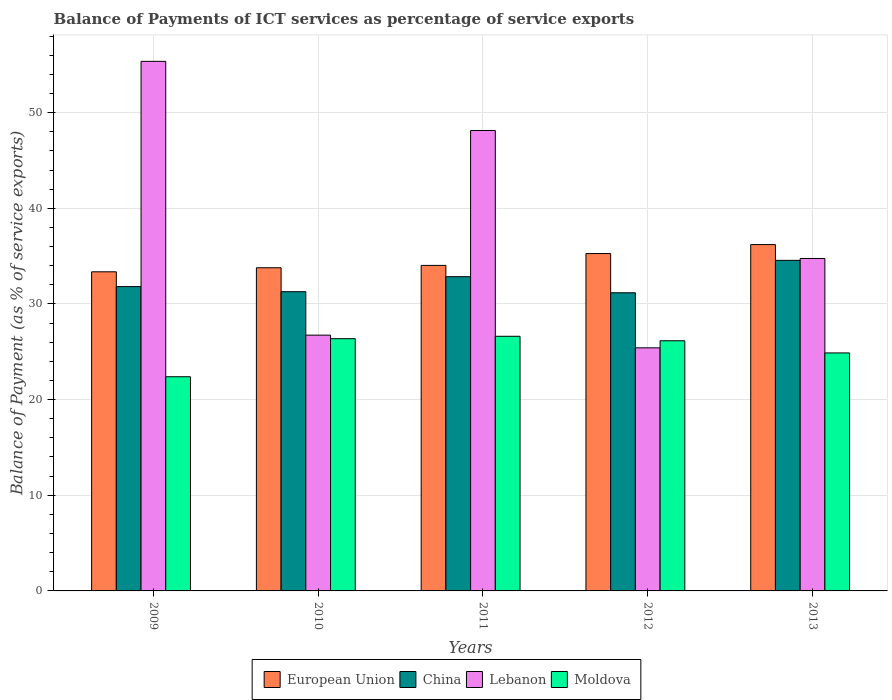Are the number of bars per tick equal to the number of legend labels?
Make the answer very short. Yes. Are the number of bars on each tick of the X-axis equal?
Provide a succinct answer. Yes. How many bars are there on the 4th tick from the left?
Your answer should be compact. 4. How many bars are there on the 4th tick from the right?
Provide a short and direct response. 4. In how many cases, is the number of bars for a given year not equal to the number of legend labels?
Provide a short and direct response. 0. What is the balance of payments of ICT services in China in 2013?
Provide a short and direct response. 34.56. Across all years, what is the maximum balance of payments of ICT services in Moldova?
Ensure brevity in your answer.  26.62. Across all years, what is the minimum balance of payments of ICT services in European Union?
Provide a succinct answer. 33.36. What is the total balance of payments of ICT services in European Union in the graph?
Your answer should be very brief. 172.64. What is the difference between the balance of payments of ICT services in Moldova in 2009 and that in 2011?
Offer a terse response. -4.23. What is the difference between the balance of payments of ICT services in Moldova in 2010 and the balance of payments of ICT services in China in 2013?
Your response must be concise. -8.19. What is the average balance of payments of ICT services in China per year?
Give a very brief answer. 32.33. In the year 2010, what is the difference between the balance of payments of ICT services in Lebanon and balance of payments of ICT services in Moldova?
Offer a very short reply. 0.37. What is the ratio of the balance of payments of ICT services in Lebanon in 2009 to that in 2011?
Keep it short and to the point. 1.15. Is the balance of payments of ICT services in Moldova in 2009 less than that in 2013?
Your answer should be very brief. Yes. What is the difference between the highest and the second highest balance of payments of ICT services in Moldova?
Make the answer very short. 0.25. What is the difference between the highest and the lowest balance of payments of ICT services in Moldova?
Offer a terse response. 4.23. Is the sum of the balance of payments of ICT services in Moldova in 2012 and 2013 greater than the maximum balance of payments of ICT services in China across all years?
Keep it short and to the point. Yes. Is it the case that in every year, the sum of the balance of payments of ICT services in European Union and balance of payments of ICT services in China is greater than the sum of balance of payments of ICT services in Moldova and balance of payments of ICT services in Lebanon?
Your answer should be very brief. Yes. What does the 4th bar from the left in 2011 represents?
Your answer should be compact. Moldova. What does the 3rd bar from the right in 2010 represents?
Make the answer very short. China. How many bars are there?
Offer a terse response. 20. Are all the bars in the graph horizontal?
Make the answer very short. No. How many years are there in the graph?
Give a very brief answer. 5. Are the values on the major ticks of Y-axis written in scientific E-notation?
Your answer should be compact. No. How are the legend labels stacked?
Your response must be concise. Horizontal. What is the title of the graph?
Offer a very short reply. Balance of Payments of ICT services as percentage of service exports. What is the label or title of the Y-axis?
Give a very brief answer. Balance of Payment (as % of service exports). What is the Balance of Payment (as % of service exports) of European Union in 2009?
Offer a very short reply. 33.36. What is the Balance of Payment (as % of service exports) of China in 2009?
Your answer should be very brief. 31.81. What is the Balance of Payment (as % of service exports) of Lebanon in 2009?
Keep it short and to the point. 55.36. What is the Balance of Payment (as % of service exports) in Moldova in 2009?
Keep it short and to the point. 22.39. What is the Balance of Payment (as % of service exports) of European Union in 2010?
Offer a terse response. 33.78. What is the Balance of Payment (as % of service exports) of China in 2010?
Provide a succinct answer. 31.28. What is the Balance of Payment (as % of service exports) in Lebanon in 2010?
Your answer should be very brief. 26.74. What is the Balance of Payment (as % of service exports) in Moldova in 2010?
Your answer should be compact. 26.37. What is the Balance of Payment (as % of service exports) in European Union in 2011?
Offer a very short reply. 34.03. What is the Balance of Payment (as % of service exports) of China in 2011?
Your answer should be very brief. 32.85. What is the Balance of Payment (as % of service exports) of Lebanon in 2011?
Provide a succinct answer. 48.13. What is the Balance of Payment (as % of service exports) of Moldova in 2011?
Make the answer very short. 26.62. What is the Balance of Payment (as % of service exports) in European Union in 2012?
Your response must be concise. 35.27. What is the Balance of Payment (as % of service exports) in China in 2012?
Keep it short and to the point. 31.17. What is the Balance of Payment (as % of service exports) of Lebanon in 2012?
Provide a short and direct response. 25.41. What is the Balance of Payment (as % of service exports) of Moldova in 2012?
Your answer should be compact. 26.15. What is the Balance of Payment (as % of service exports) in European Union in 2013?
Offer a terse response. 36.2. What is the Balance of Payment (as % of service exports) in China in 2013?
Keep it short and to the point. 34.56. What is the Balance of Payment (as % of service exports) in Lebanon in 2013?
Your answer should be compact. 34.75. What is the Balance of Payment (as % of service exports) of Moldova in 2013?
Offer a terse response. 24.88. Across all years, what is the maximum Balance of Payment (as % of service exports) in European Union?
Your answer should be very brief. 36.2. Across all years, what is the maximum Balance of Payment (as % of service exports) in China?
Ensure brevity in your answer.  34.56. Across all years, what is the maximum Balance of Payment (as % of service exports) of Lebanon?
Ensure brevity in your answer.  55.36. Across all years, what is the maximum Balance of Payment (as % of service exports) of Moldova?
Provide a short and direct response. 26.62. Across all years, what is the minimum Balance of Payment (as % of service exports) of European Union?
Your answer should be compact. 33.36. Across all years, what is the minimum Balance of Payment (as % of service exports) of China?
Provide a short and direct response. 31.17. Across all years, what is the minimum Balance of Payment (as % of service exports) in Lebanon?
Make the answer very short. 25.41. Across all years, what is the minimum Balance of Payment (as % of service exports) in Moldova?
Your answer should be compact. 22.39. What is the total Balance of Payment (as % of service exports) of European Union in the graph?
Make the answer very short. 172.64. What is the total Balance of Payment (as % of service exports) of China in the graph?
Your answer should be very brief. 161.66. What is the total Balance of Payment (as % of service exports) in Lebanon in the graph?
Your answer should be very brief. 190.39. What is the total Balance of Payment (as % of service exports) in Moldova in the graph?
Ensure brevity in your answer.  126.4. What is the difference between the Balance of Payment (as % of service exports) in European Union in 2009 and that in 2010?
Your answer should be very brief. -0.42. What is the difference between the Balance of Payment (as % of service exports) of China in 2009 and that in 2010?
Provide a short and direct response. 0.53. What is the difference between the Balance of Payment (as % of service exports) in Lebanon in 2009 and that in 2010?
Your response must be concise. 28.62. What is the difference between the Balance of Payment (as % of service exports) in Moldova in 2009 and that in 2010?
Offer a terse response. -3.98. What is the difference between the Balance of Payment (as % of service exports) of European Union in 2009 and that in 2011?
Ensure brevity in your answer.  -0.67. What is the difference between the Balance of Payment (as % of service exports) of China in 2009 and that in 2011?
Provide a short and direct response. -1.04. What is the difference between the Balance of Payment (as % of service exports) of Lebanon in 2009 and that in 2011?
Make the answer very short. 7.23. What is the difference between the Balance of Payment (as % of service exports) in Moldova in 2009 and that in 2011?
Your response must be concise. -4.23. What is the difference between the Balance of Payment (as % of service exports) in European Union in 2009 and that in 2012?
Give a very brief answer. -1.91. What is the difference between the Balance of Payment (as % of service exports) of China in 2009 and that in 2012?
Your answer should be very brief. 0.65. What is the difference between the Balance of Payment (as % of service exports) in Lebanon in 2009 and that in 2012?
Your answer should be compact. 29.95. What is the difference between the Balance of Payment (as % of service exports) of Moldova in 2009 and that in 2012?
Make the answer very short. -3.76. What is the difference between the Balance of Payment (as % of service exports) of European Union in 2009 and that in 2013?
Offer a terse response. -2.84. What is the difference between the Balance of Payment (as % of service exports) of China in 2009 and that in 2013?
Provide a short and direct response. -2.74. What is the difference between the Balance of Payment (as % of service exports) in Lebanon in 2009 and that in 2013?
Your answer should be compact. 20.61. What is the difference between the Balance of Payment (as % of service exports) of Moldova in 2009 and that in 2013?
Provide a succinct answer. -2.49. What is the difference between the Balance of Payment (as % of service exports) of European Union in 2010 and that in 2011?
Give a very brief answer. -0.25. What is the difference between the Balance of Payment (as % of service exports) of China in 2010 and that in 2011?
Give a very brief answer. -1.57. What is the difference between the Balance of Payment (as % of service exports) of Lebanon in 2010 and that in 2011?
Ensure brevity in your answer.  -21.39. What is the difference between the Balance of Payment (as % of service exports) of Moldova in 2010 and that in 2011?
Your response must be concise. -0.25. What is the difference between the Balance of Payment (as % of service exports) of European Union in 2010 and that in 2012?
Offer a very short reply. -1.48. What is the difference between the Balance of Payment (as % of service exports) in China in 2010 and that in 2012?
Make the answer very short. 0.11. What is the difference between the Balance of Payment (as % of service exports) in Lebanon in 2010 and that in 2012?
Give a very brief answer. 1.33. What is the difference between the Balance of Payment (as % of service exports) in Moldova in 2010 and that in 2012?
Offer a terse response. 0.22. What is the difference between the Balance of Payment (as % of service exports) in European Union in 2010 and that in 2013?
Keep it short and to the point. -2.42. What is the difference between the Balance of Payment (as % of service exports) in China in 2010 and that in 2013?
Your response must be concise. -3.28. What is the difference between the Balance of Payment (as % of service exports) in Lebanon in 2010 and that in 2013?
Provide a short and direct response. -8.02. What is the difference between the Balance of Payment (as % of service exports) of Moldova in 2010 and that in 2013?
Give a very brief answer. 1.49. What is the difference between the Balance of Payment (as % of service exports) of European Union in 2011 and that in 2012?
Your answer should be very brief. -1.24. What is the difference between the Balance of Payment (as % of service exports) of China in 2011 and that in 2012?
Offer a very short reply. 1.68. What is the difference between the Balance of Payment (as % of service exports) of Lebanon in 2011 and that in 2012?
Your answer should be very brief. 22.72. What is the difference between the Balance of Payment (as % of service exports) in Moldova in 2011 and that in 2012?
Provide a short and direct response. 0.47. What is the difference between the Balance of Payment (as % of service exports) in European Union in 2011 and that in 2013?
Keep it short and to the point. -2.17. What is the difference between the Balance of Payment (as % of service exports) in China in 2011 and that in 2013?
Ensure brevity in your answer.  -1.71. What is the difference between the Balance of Payment (as % of service exports) of Lebanon in 2011 and that in 2013?
Your answer should be compact. 13.38. What is the difference between the Balance of Payment (as % of service exports) of Moldova in 2011 and that in 2013?
Your response must be concise. 1.74. What is the difference between the Balance of Payment (as % of service exports) in European Union in 2012 and that in 2013?
Provide a short and direct response. -0.94. What is the difference between the Balance of Payment (as % of service exports) of China in 2012 and that in 2013?
Offer a very short reply. -3.39. What is the difference between the Balance of Payment (as % of service exports) of Lebanon in 2012 and that in 2013?
Your response must be concise. -9.34. What is the difference between the Balance of Payment (as % of service exports) in Moldova in 2012 and that in 2013?
Your answer should be compact. 1.27. What is the difference between the Balance of Payment (as % of service exports) of European Union in 2009 and the Balance of Payment (as % of service exports) of China in 2010?
Offer a very short reply. 2.08. What is the difference between the Balance of Payment (as % of service exports) of European Union in 2009 and the Balance of Payment (as % of service exports) of Lebanon in 2010?
Offer a very short reply. 6.62. What is the difference between the Balance of Payment (as % of service exports) in European Union in 2009 and the Balance of Payment (as % of service exports) in Moldova in 2010?
Make the answer very short. 6.99. What is the difference between the Balance of Payment (as % of service exports) in China in 2009 and the Balance of Payment (as % of service exports) in Lebanon in 2010?
Offer a very short reply. 5.07. What is the difference between the Balance of Payment (as % of service exports) in China in 2009 and the Balance of Payment (as % of service exports) in Moldova in 2010?
Provide a succinct answer. 5.44. What is the difference between the Balance of Payment (as % of service exports) in Lebanon in 2009 and the Balance of Payment (as % of service exports) in Moldova in 2010?
Your answer should be very brief. 28.99. What is the difference between the Balance of Payment (as % of service exports) in European Union in 2009 and the Balance of Payment (as % of service exports) in China in 2011?
Your response must be concise. 0.51. What is the difference between the Balance of Payment (as % of service exports) in European Union in 2009 and the Balance of Payment (as % of service exports) in Lebanon in 2011?
Make the answer very short. -14.77. What is the difference between the Balance of Payment (as % of service exports) of European Union in 2009 and the Balance of Payment (as % of service exports) of Moldova in 2011?
Offer a terse response. 6.74. What is the difference between the Balance of Payment (as % of service exports) in China in 2009 and the Balance of Payment (as % of service exports) in Lebanon in 2011?
Provide a short and direct response. -16.32. What is the difference between the Balance of Payment (as % of service exports) of China in 2009 and the Balance of Payment (as % of service exports) of Moldova in 2011?
Your response must be concise. 5.19. What is the difference between the Balance of Payment (as % of service exports) in Lebanon in 2009 and the Balance of Payment (as % of service exports) in Moldova in 2011?
Offer a very short reply. 28.74. What is the difference between the Balance of Payment (as % of service exports) in European Union in 2009 and the Balance of Payment (as % of service exports) in China in 2012?
Ensure brevity in your answer.  2.19. What is the difference between the Balance of Payment (as % of service exports) in European Union in 2009 and the Balance of Payment (as % of service exports) in Lebanon in 2012?
Keep it short and to the point. 7.95. What is the difference between the Balance of Payment (as % of service exports) in European Union in 2009 and the Balance of Payment (as % of service exports) in Moldova in 2012?
Make the answer very short. 7.21. What is the difference between the Balance of Payment (as % of service exports) in China in 2009 and the Balance of Payment (as % of service exports) in Lebanon in 2012?
Your response must be concise. 6.4. What is the difference between the Balance of Payment (as % of service exports) of China in 2009 and the Balance of Payment (as % of service exports) of Moldova in 2012?
Offer a terse response. 5.66. What is the difference between the Balance of Payment (as % of service exports) of Lebanon in 2009 and the Balance of Payment (as % of service exports) of Moldova in 2012?
Give a very brief answer. 29.21. What is the difference between the Balance of Payment (as % of service exports) in European Union in 2009 and the Balance of Payment (as % of service exports) in China in 2013?
Offer a very short reply. -1.2. What is the difference between the Balance of Payment (as % of service exports) of European Union in 2009 and the Balance of Payment (as % of service exports) of Lebanon in 2013?
Offer a very short reply. -1.39. What is the difference between the Balance of Payment (as % of service exports) in European Union in 2009 and the Balance of Payment (as % of service exports) in Moldova in 2013?
Offer a very short reply. 8.48. What is the difference between the Balance of Payment (as % of service exports) of China in 2009 and the Balance of Payment (as % of service exports) of Lebanon in 2013?
Offer a terse response. -2.94. What is the difference between the Balance of Payment (as % of service exports) of China in 2009 and the Balance of Payment (as % of service exports) of Moldova in 2013?
Provide a short and direct response. 6.93. What is the difference between the Balance of Payment (as % of service exports) of Lebanon in 2009 and the Balance of Payment (as % of service exports) of Moldova in 2013?
Your answer should be very brief. 30.48. What is the difference between the Balance of Payment (as % of service exports) in European Union in 2010 and the Balance of Payment (as % of service exports) in China in 2011?
Provide a succinct answer. 0.93. What is the difference between the Balance of Payment (as % of service exports) of European Union in 2010 and the Balance of Payment (as % of service exports) of Lebanon in 2011?
Offer a terse response. -14.35. What is the difference between the Balance of Payment (as % of service exports) of European Union in 2010 and the Balance of Payment (as % of service exports) of Moldova in 2011?
Your response must be concise. 7.16. What is the difference between the Balance of Payment (as % of service exports) in China in 2010 and the Balance of Payment (as % of service exports) in Lebanon in 2011?
Provide a succinct answer. -16.85. What is the difference between the Balance of Payment (as % of service exports) in China in 2010 and the Balance of Payment (as % of service exports) in Moldova in 2011?
Your answer should be very brief. 4.66. What is the difference between the Balance of Payment (as % of service exports) in Lebanon in 2010 and the Balance of Payment (as % of service exports) in Moldova in 2011?
Your response must be concise. 0.12. What is the difference between the Balance of Payment (as % of service exports) in European Union in 2010 and the Balance of Payment (as % of service exports) in China in 2012?
Offer a very short reply. 2.62. What is the difference between the Balance of Payment (as % of service exports) of European Union in 2010 and the Balance of Payment (as % of service exports) of Lebanon in 2012?
Your answer should be very brief. 8.37. What is the difference between the Balance of Payment (as % of service exports) of European Union in 2010 and the Balance of Payment (as % of service exports) of Moldova in 2012?
Provide a succinct answer. 7.63. What is the difference between the Balance of Payment (as % of service exports) of China in 2010 and the Balance of Payment (as % of service exports) of Lebanon in 2012?
Ensure brevity in your answer.  5.87. What is the difference between the Balance of Payment (as % of service exports) in China in 2010 and the Balance of Payment (as % of service exports) in Moldova in 2012?
Provide a short and direct response. 5.13. What is the difference between the Balance of Payment (as % of service exports) in Lebanon in 2010 and the Balance of Payment (as % of service exports) in Moldova in 2012?
Offer a very short reply. 0.59. What is the difference between the Balance of Payment (as % of service exports) in European Union in 2010 and the Balance of Payment (as % of service exports) in China in 2013?
Provide a succinct answer. -0.77. What is the difference between the Balance of Payment (as % of service exports) of European Union in 2010 and the Balance of Payment (as % of service exports) of Lebanon in 2013?
Your answer should be compact. -0.97. What is the difference between the Balance of Payment (as % of service exports) in European Union in 2010 and the Balance of Payment (as % of service exports) in Moldova in 2013?
Your response must be concise. 8.9. What is the difference between the Balance of Payment (as % of service exports) in China in 2010 and the Balance of Payment (as % of service exports) in Lebanon in 2013?
Provide a short and direct response. -3.47. What is the difference between the Balance of Payment (as % of service exports) of China in 2010 and the Balance of Payment (as % of service exports) of Moldova in 2013?
Offer a terse response. 6.4. What is the difference between the Balance of Payment (as % of service exports) in Lebanon in 2010 and the Balance of Payment (as % of service exports) in Moldova in 2013?
Provide a succinct answer. 1.86. What is the difference between the Balance of Payment (as % of service exports) of European Union in 2011 and the Balance of Payment (as % of service exports) of China in 2012?
Your answer should be very brief. 2.86. What is the difference between the Balance of Payment (as % of service exports) in European Union in 2011 and the Balance of Payment (as % of service exports) in Lebanon in 2012?
Provide a succinct answer. 8.62. What is the difference between the Balance of Payment (as % of service exports) in European Union in 2011 and the Balance of Payment (as % of service exports) in Moldova in 2012?
Keep it short and to the point. 7.88. What is the difference between the Balance of Payment (as % of service exports) in China in 2011 and the Balance of Payment (as % of service exports) in Lebanon in 2012?
Make the answer very short. 7.44. What is the difference between the Balance of Payment (as % of service exports) in China in 2011 and the Balance of Payment (as % of service exports) in Moldova in 2012?
Your response must be concise. 6.7. What is the difference between the Balance of Payment (as % of service exports) of Lebanon in 2011 and the Balance of Payment (as % of service exports) of Moldova in 2012?
Provide a short and direct response. 21.98. What is the difference between the Balance of Payment (as % of service exports) in European Union in 2011 and the Balance of Payment (as % of service exports) in China in 2013?
Your answer should be very brief. -0.53. What is the difference between the Balance of Payment (as % of service exports) of European Union in 2011 and the Balance of Payment (as % of service exports) of Lebanon in 2013?
Offer a terse response. -0.72. What is the difference between the Balance of Payment (as % of service exports) of European Union in 2011 and the Balance of Payment (as % of service exports) of Moldova in 2013?
Your answer should be very brief. 9.15. What is the difference between the Balance of Payment (as % of service exports) in China in 2011 and the Balance of Payment (as % of service exports) in Lebanon in 2013?
Your answer should be very brief. -1.9. What is the difference between the Balance of Payment (as % of service exports) in China in 2011 and the Balance of Payment (as % of service exports) in Moldova in 2013?
Your answer should be compact. 7.97. What is the difference between the Balance of Payment (as % of service exports) in Lebanon in 2011 and the Balance of Payment (as % of service exports) in Moldova in 2013?
Your answer should be very brief. 23.25. What is the difference between the Balance of Payment (as % of service exports) of European Union in 2012 and the Balance of Payment (as % of service exports) of China in 2013?
Keep it short and to the point. 0.71. What is the difference between the Balance of Payment (as % of service exports) of European Union in 2012 and the Balance of Payment (as % of service exports) of Lebanon in 2013?
Provide a succinct answer. 0.51. What is the difference between the Balance of Payment (as % of service exports) in European Union in 2012 and the Balance of Payment (as % of service exports) in Moldova in 2013?
Provide a short and direct response. 10.39. What is the difference between the Balance of Payment (as % of service exports) of China in 2012 and the Balance of Payment (as % of service exports) of Lebanon in 2013?
Keep it short and to the point. -3.59. What is the difference between the Balance of Payment (as % of service exports) in China in 2012 and the Balance of Payment (as % of service exports) in Moldova in 2013?
Provide a succinct answer. 6.29. What is the difference between the Balance of Payment (as % of service exports) of Lebanon in 2012 and the Balance of Payment (as % of service exports) of Moldova in 2013?
Ensure brevity in your answer.  0.53. What is the average Balance of Payment (as % of service exports) in European Union per year?
Offer a very short reply. 34.53. What is the average Balance of Payment (as % of service exports) in China per year?
Ensure brevity in your answer.  32.33. What is the average Balance of Payment (as % of service exports) of Lebanon per year?
Your response must be concise. 38.08. What is the average Balance of Payment (as % of service exports) of Moldova per year?
Keep it short and to the point. 25.28. In the year 2009, what is the difference between the Balance of Payment (as % of service exports) in European Union and Balance of Payment (as % of service exports) in China?
Provide a succinct answer. 1.55. In the year 2009, what is the difference between the Balance of Payment (as % of service exports) of European Union and Balance of Payment (as % of service exports) of Lebanon?
Keep it short and to the point. -22. In the year 2009, what is the difference between the Balance of Payment (as % of service exports) in European Union and Balance of Payment (as % of service exports) in Moldova?
Ensure brevity in your answer.  10.97. In the year 2009, what is the difference between the Balance of Payment (as % of service exports) in China and Balance of Payment (as % of service exports) in Lebanon?
Keep it short and to the point. -23.55. In the year 2009, what is the difference between the Balance of Payment (as % of service exports) of China and Balance of Payment (as % of service exports) of Moldova?
Provide a short and direct response. 9.42. In the year 2009, what is the difference between the Balance of Payment (as % of service exports) in Lebanon and Balance of Payment (as % of service exports) in Moldova?
Ensure brevity in your answer.  32.97. In the year 2010, what is the difference between the Balance of Payment (as % of service exports) of European Union and Balance of Payment (as % of service exports) of China?
Offer a very short reply. 2.5. In the year 2010, what is the difference between the Balance of Payment (as % of service exports) in European Union and Balance of Payment (as % of service exports) in Lebanon?
Your answer should be compact. 7.04. In the year 2010, what is the difference between the Balance of Payment (as % of service exports) of European Union and Balance of Payment (as % of service exports) of Moldova?
Your answer should be compact. 7.41. In the year 2010, what is the difference between the Balance of Payment (as % of service exports) of China and Balance of Payment (as % of service exports) of Lebanon?
Your answer should be very brief. 4.54. In the year 2010, what is the difference between the Balance of Payment (as % of service exports) of China and Balance of Payment (as % of service exports) of Moldova?
Make the answer very short. 4.91. In the year 2010, what is the difference between the Balance of Payment (as % of service exports) of Lebanon and Balance of Payment (as % of service exports) of Moldova?
Offer a terse response. 0.37. In the year 2011, what is the difference between the Balance of Payment (as % of service exports) in European Union and Balance of Payment (as % of service exports) in China?
Your response must be concise. 1.18. In the year 2011, what is the difference between the Balance of Payment (as % of service exports) in European Union and Balance of Payment (as % of service exports) in Lebanon?
Your answer should be very brief. -14.1. In the year 2011, what is the difference between the Balance of Payment (as % of service exports) in European Union and Balance of Payment (as % of service exports) in Moldova?
Your answer should be compact. 7.41. In the year 2011, what is the difference between the Balance of Payment (as % of service exports) of China and Balance of Payment (as % of service exports) of Lebanon?
Offer a very short reply. -15.28. In the year 2011, what is the difference between the Balance of Payment (as % of service exports) in China and Balance of Payment (as % of service exports) in Moldova?
Offer a terse response. 6.23. In the year 2011, what is the difference between the Balance of Payment (as % of service exports) in Lebanon and Balance of Payment (as % of service exports) in Moldova?
Offer a very short reply. 21.51. In the year 2012, what is the difference between the Balance of Payment (as % of service exports) in European Union and Balance of Payment (as % of service exports) in China?
Offer a terse response. 4.1. In the year 2012, what is the difference between the Balance of Payment (as % of service exports) of European Union and Balance of Payment (as % of service exports) of Lebanon?
Ensure brevity in your answer.  9.85. In the year 2012, what is the difference between the Balance of Payment (as % of service exports) of European Union and Balance of Payment (as % of service exports) of Moldova?
Provide a short and direct response. 9.12. In the year 2012, what is the difference between the Balance of Payment (as % of service exports) in China and Balance of Payment (as % of service exports) in Lebanon?
Your answer should be very brief. 5.75. In the year 2012, what is the difference between the Balance of Payment (as % of service exports) in China and Balance of Payment (as % of service exports) in Moldova?
Keep it short and to the point. 5.02. In the year 2012, what is the difference between the Balance of Payment (as % of service exports) in Lebanon and Balance of Payment (as % of service exports) in Moldova?
Make the answer very short. -0.74. In the year 2013, what is the difference between the Balance of Payment (as % of service exports) in European Union and Balance of Payment (as % of service exports) in China?
Offer a very short reply. 1.65. In the year 2013, what is the difference between the Balance of Payment (as % of service exports) in European Union and Balance of Payment (as % of service exports) in Lebanon?
Make the answer very short. 1.45. In the year 2013, what is the difference between the Balance of Payment (as % of service exports) of European Union and Balance of Payment (as % of service exports) of Moldova?
Provide a short and direct response. 11.32. In the year 2013, what is the difference between the Balance of Payment (as % of service exports) in China and Balance of Payment (as % of service exports) in Lebanon?
Ensure brevity in your answer.  -0.2. In the year 2013, what is the difference between the Balance of Payment (as % of service exports) of China and Balance of Payment (as % of service exports) of Moldova?
Your response must be concise. 9.68. In the year 2013, what is the difference between the Balance of Payment (as % of service exports) in Lebanon and Balance of Payment (as % of service exports) in Moldova?
Your response must be concise. 9.87. What is the ratio of the Balance of Payment (as % of service exports) in European Union in 2009 to that in 2010?
Your answer should be very brief. 0.99. What is the ratio of the Balance of Payment (as % of service exports) of Lebanon in 2009 to that in 2010?
Ensure brevity in your answer.  2.07. What is the ratio of the Balance of Payment (as % of service exports) in Moldova in 2009 to that in 2010?
Offer a very short reply. 0.85. What is the ratio of the Balance of Payment (as % of service exports) in European Union in 2009 to that in 2011?
Give a very brief answer. 0.98. What is the ratio of the Balance of Payment (as % of service exports) in China in 2009 to that in 2011?
Offer a very short reply. 0.97. What is the ratio of the Balance of Payment (as % of service exports) of Lebanon in 2009 to that in 2011?
Your response must be concise. 1.15. What is the ratio of the Balance of Payment (as % of service exports) in Moldova in 2009 to that in 2011?
Provide a succinct answer. 0.84. What is the ratio of the Balance of Payment (as % of service exports) of European Union in 2009 to that in 2012?
Keep it short and to the point. 0.95. What is the ratio of the Balance of Payment (as % of service exports) of China in 2009 to that in 2012?
Offer a very short reply. 1.02. What is the ratio of the Balance of Payment (as % of service exports) of Lebanon in 2009 to that in 2012?
Your answer should be very brief. 2.18. What is the ratio of the Balance of Payment (as % of service exports) of Moldova in 2009 to that in 2012?
Give a very brief answer. 0.86. What is the ratio of the Balance of Payment (as % of service exports) in European Union in 2009 to that in 2013?
Offer a terse response. 0.92. What is the ratio of the Balance of Payment (as % of service exports) of China in 2009 to that in 2013?
Offer a terse response. 0.92. What is the ratio of the Balance of Payment (as % of service exports) in Lebanon in 2009 to that in 2013?
Ensure brevity in your answer.  1.59. What is the ratio of the Balance of Payment (as % of service exports) in China in 2010 to that in 2011?
Your answer should be compact. 0.95. What is the ratio of the Balance of Payment (as % of service exports) of Lebanon in 2010 to that in 2011?
Give a very brief answer. 0.56. What is the ratio of the Balance of Payment (as % of service exports) in Moldova in 2010 to that in 2011?
Keep it short and to the point. 0.99. What is the ratio of the Balance of Payment (as % of service exports) in European Union in 2010 to that in 2012?
Your answer should be very brief. 0.96. What is the ratio of the Balance of Payment (as % of service exports) of Lebanon in 2010 to that in 2012?
Keep it short and to the point. 1.05. What is the ratio of the Balance of Payment (as % of service exports) of Moldova in 2010 to that in 2012?
Offer a terse response. 1.01. What is the ratio of the Balance of Payment (as % of service exports) of European Union in 2010 to that in 2013?
Make the answer very short. 0.93. What is the ratio of the Balance of Payment (as % of service exports) of China in 2010 to that in 2013?
Offer a very short reply. 0.91. What is the ratio of the Balance of Payment (as % of service exports) in Lebanon in 2010 to that in 2013?
Your response must be concise. 0.77. What is the ratio of the Balance of Payment (as % of service exports) in Moldova in 2010 to that in 2013?
Make the answer very short. 1.06. What is the ratio of the Balance of Payment (as % of service exports) of European Union in 2011 to that in 2012?
Offer a terse response. 0.96. What is the ratio of the Balance of Payment (as % of service exports) in China in 2011 to that in 2012?
Your answer should be compact. 1.05. What is the ratio of the Balance of Payment (as % of service exports) in Lebanon in 2011 to that in 2012?
Make the answer very short. 1.89. What is the ratio of the Balance of Payment (as % of service exports) of Moldova in 2011 to that in 2012?
Provide a succinct answer. 1.02. What is the ratio of the Balance of Payment (as % of service exports) of European Union in 2011 to that in 2013?
Offer a terse response. 0.94. What is the ratio of the Balance of Payment (as % of service exports) in China in 2011 to that in 2013?
Your response must be concise. 0.95. What is the ratio of the Balance of Payment (as % of service exports) in Lebanon in 2011 to that in 2013?
Give a very brief answer. 1.38. What is the ratio of the Balance of Payment (as % of service exports) in Moldova in 2011 to that in 2013?
Give a very brief answer. 1.07. What is the ratio of the Balance of Payment (as % of service exports) of European Union in 2012 to that in 2013?
Your response must be concise. 0.97. What is the ratio of the Balance of Payment (as % of service exports) in China in 2012 to that in 2013?
Provide a succinct answer. 0.9. What is the ratio of the Balance of Payment (as % of service exports) in Lebanon in 2012 to that in 2013?
Offer a terse response. 0.73. What is the ratio of the Balance of Payment (as % of service exports) in Moldova in 2012 to that in 2013?
Make the answer very short. 1.05. What is the difference between the highest and the second highest Balance of Payment (as % of service exports) of European Union?
Provide a short and direct response. 0.94. What is the difference between the highest and the second highest Balance of Payment (as % of service exports) in China?
Your answer should be compact. 1.71. What is the difference between the highest and the second highest Balance of Payment (as % of service exports) in Lebanon?
Make the answer very short. 7.23. What is the difference between the highest and the second highest Balance of Payment (as % of service exports) of Moldova?
Your response must be concise. 0.25. What is the difference between the highest and the lowest Balance of Payment (as % of service exports) of European Union?
Your response must be concise. 2.84. What is the difference between the highest and the lowest Balance of Payment (as % of service exports) of China?
Your answer should be very brief. 3.39. What is the difference between the highest and the lowest Balance of Payment (as % of service exports) of Lebanon?
Give a very brief answer. 29.95. What is the difference between the highest and the lowest Balance of Payment (as % of service exports) of Moldova?
Provide a succinct answer. 4.23. 